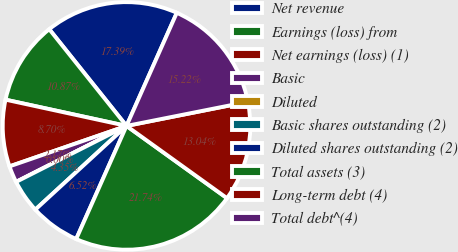<chart> <loc_0><loc_0><loc_500><loc_500><pie_chart><fcel>Net revenue<fcel>Earnings (loss) from<fcel>Net earnings (loss) (1)<fcel>Basic<fcel>Diluted<fcel>Basic shares outstanding (2)<fcel>Diluted shares outstanding (2)<fcel>Total assets (3)<fcel>Long-term debt (4)<fcel>Total debt^(4)<nl><fcel>17.39%<fcel>10.87%<fcel>8.7%<fcel>2.17%<fcel>0.0%<fcel>4.35%<fcel>6.52%<fcel>21.74%<fcel>13.04%<fcel>15.22%<nl></chart> 